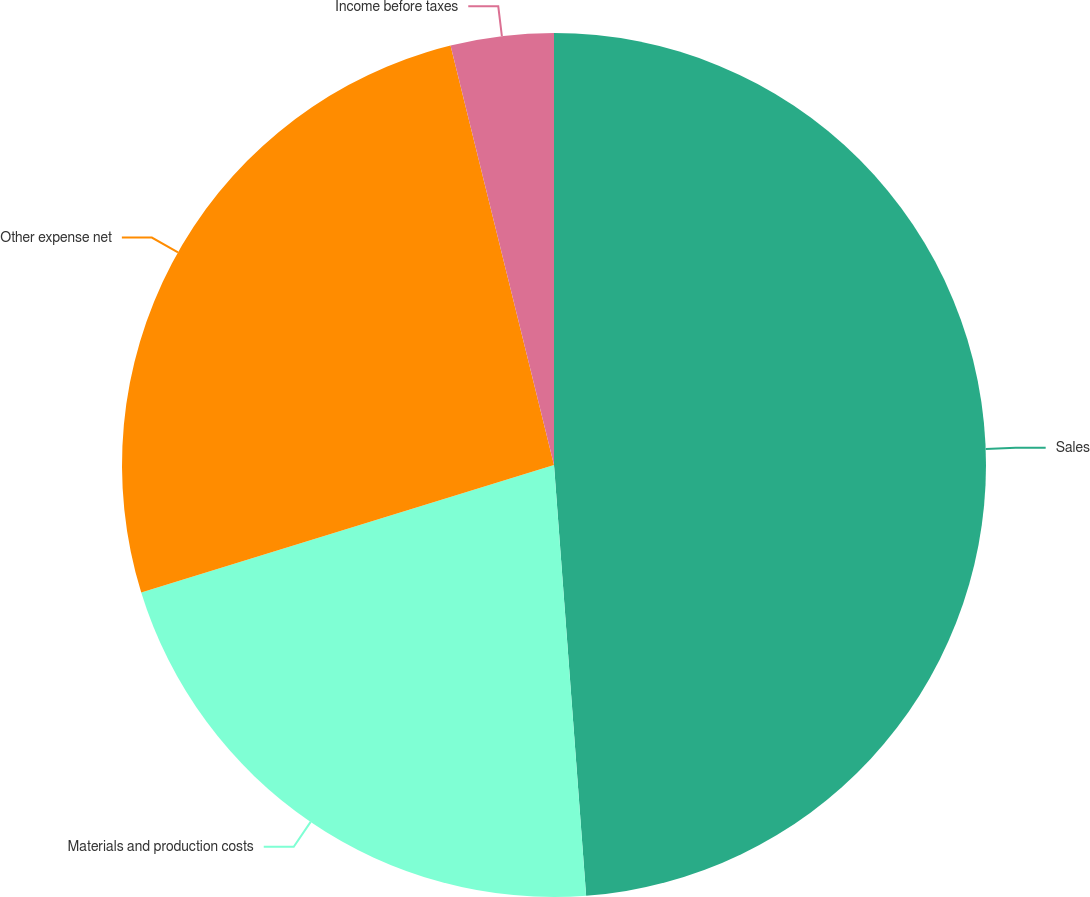Convert chart to OTSL. <chart><loc_0><loc_0><loc_500><loc_500><pie_chart><fcel>Sales<fcel>Materials and production costs<fcel>Other expense net<fcel>Income before taxes<nl><fcel>48.82%<fcel>21.42%<fcel>25.92%<fcel>3.85%<nl></chart> 